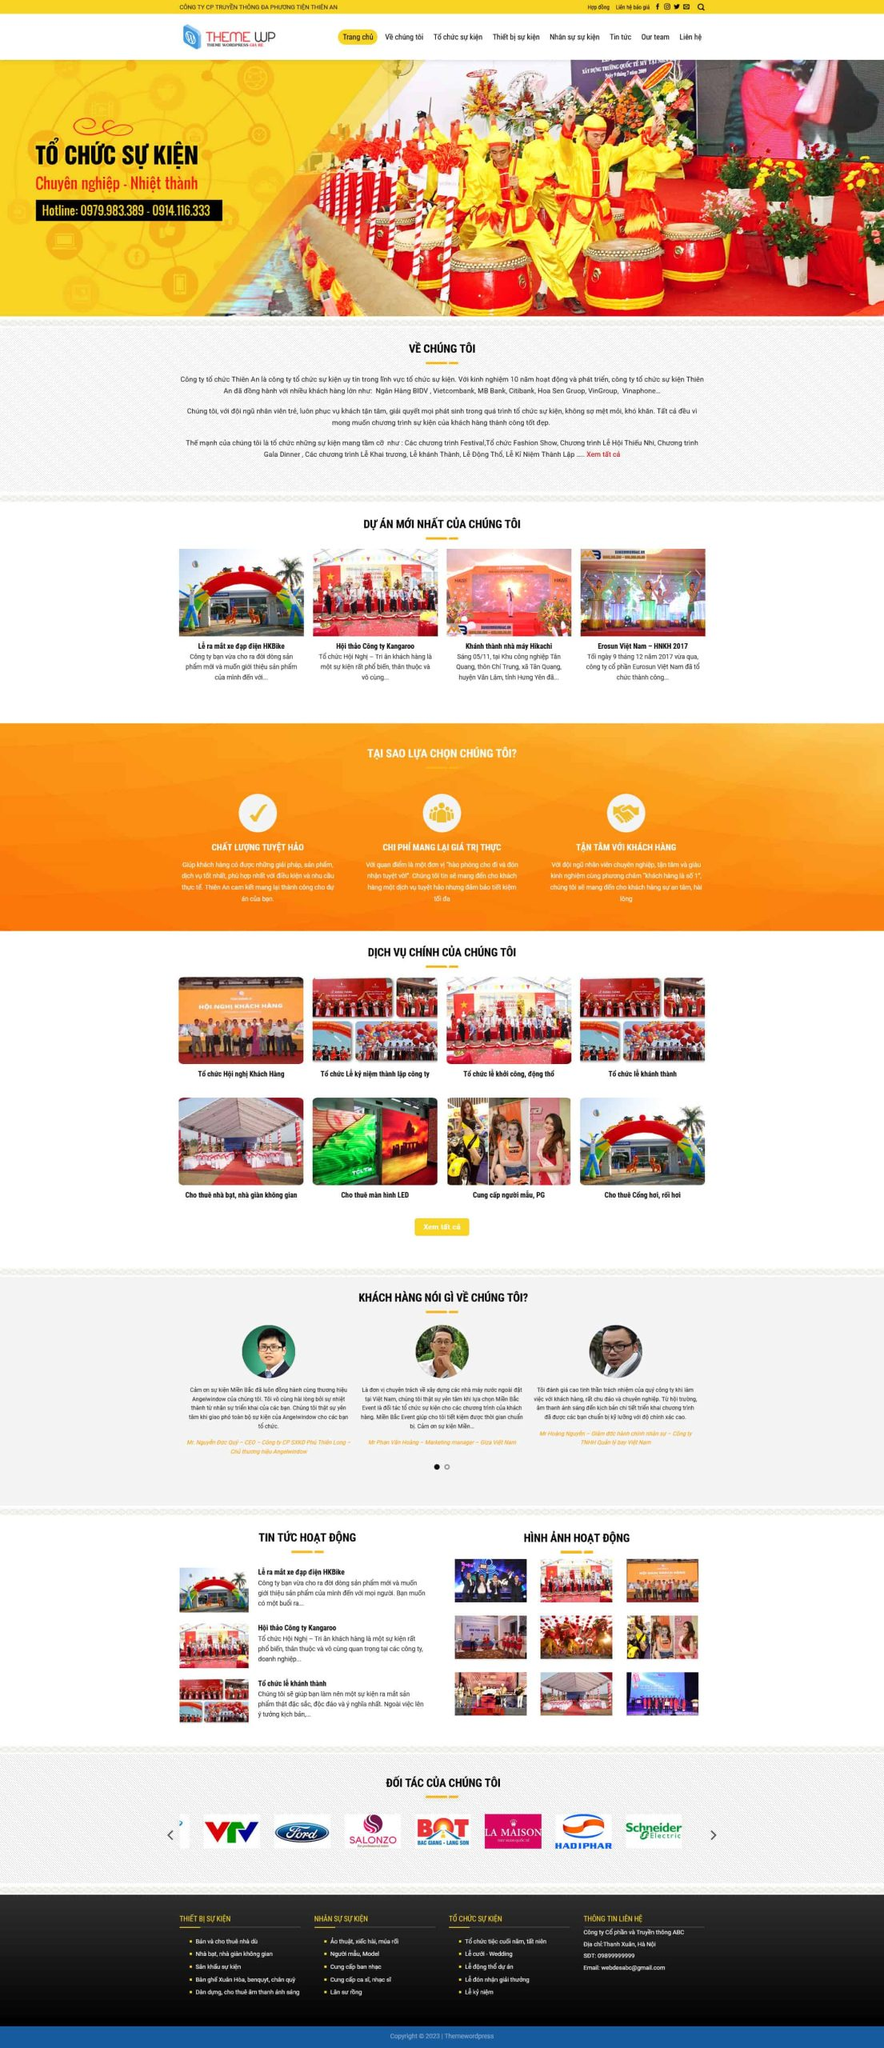Liệt kê 5 ngành nghề, lĩnh vực phù hợp với website này, phân cách các màu sắc bằng dấu phẩy. Chỉ trả về kết quả, phân cách bằng dấy phẩy
 Tổ chức sự kiện, Hội nghị khách hàng, Khánh thành, Cho thuê thiết bị sự kiện, Cung cấp người mẫu PG 